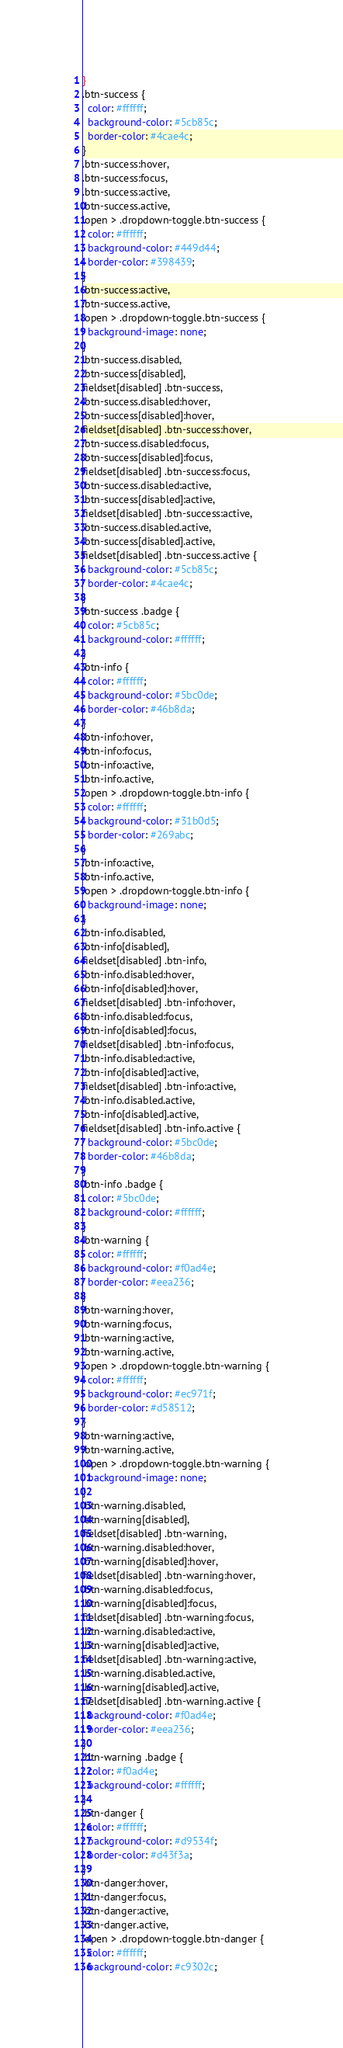<code> <loc_0><loc_0><loc_500><loc_500><_CSS_>}
.btn-success {
  color: #ffffff;
  background-color: #5cb85c;
  border-color: #4cae4c;
}
.btn-success:hover,
.btn-success:focus,
.btn-success:active,
.btn-success.active,
.open > .dropdown-toggle.btn-success {
  color: #ffffff;
  background-color: #449d44;
  border-color: #398439;
}
.btn-success:active,
.btn-success.active,
.open > .dropdown-toggle.btn-success {
  background-image: none;
}
.btn-success.disabled,
.btn-success[disabled],
fieldset[disabled] .btn-success,
.btn-success.disabled:hover,
.btn-success[disabled]:hover,
fieldset[disabled] .btn-success:hover,
.btn-success.disabled:focus,
.btn-success[disabled]:focus,
fieldset[disabled] .btn-success:focus,
.btn-success.disabled:active,
.btn-success[disabled]:active,
fieldset[disabled] .btn-success:active,
.btn-success.disabled.active,
.btn-success[disabled].active,
fieldset[disabled] .btn-success.active {
  background-color: #5cb85c;
  border-color: #4cae4c;
}
.btn-success .badge {
  color: #5cb85c;
  background-color: #ffffff;
}
.btn-info {
  color: #ffffff;
  background-color: #5bc0de;
  border-color: #46b8da;
}
.btn-info:hover,
.btn-info:focus,
.btn-info:active,
.btn-info.active,
.open > .dropdown-toggle.btn-info {
  color: #ffffff;
  background-color: #31b0d5;
  border-color: #269abc;
}
.btn-info:active,
.btn-info.active,
.open > .dropdown-toggle.btn-info {
  background-image: none;
}
.btn-info.disabled,
.btn-info[disabled],
fieldset[disabled] .btn-info,
.btn-info.disabled:hover,
.btn-info[disabled]:hover,
fieldset[disabled] .btn-info:hover,
.btn-info.disabled:focus,
.btn-info[disabled]:focus,
fieldset[disabled] .btn-info:focus,
.btn-info.disabled:active,
.btn-info[disabled]:active,
fieldset[disabled] .btn-info:active,
.btn-info.disabled.active,
.btn-info[disabled].active,
fieldset[disabled] .btn-info.active {
  background-color: #5bc0de;
  border-color: #46b8da;
}
.btn-info .badge {
  color: #5bc0de;
  background-color: #ffffff;
}
.btn-warning {
  color: #ffffff;
  background-color: #f0ad4e;
  border-color: #eea236;
}
.btn-warning:hover,
.btn-warning:focus,
.btn-warning:active,
.btn-warning.active,
.open > .dropdown-toggle.btn-warning {
  color: #ffffff;
  background-color: #ec971f;
  border-color: #d58512;
}
.btn-warning:active,
.btn-warning.active,
.open > .dropdown-toggle.btn-warning {
  background-image: none;
}
.btn-warning.disabled,
.btn-warning[disabled],
fieldset[disabled] .btn-warning,
.btn-warning.disabled:hover,
.btn-warning[disabled]:hover,
fieldset[disabled] .btn-warning:hover,
.btn-warning.disabled:focus,
.btn-warning[disabled]:focus,
fieldset[disabled] .btn-warning:focus,
.btn-warning.disabled:active,
.btn-warning[disabled]:active,
fieldset[disabled] .btn-warning:active,
.btn-warning.disabled.active,
.btn-warning[disabled].active,
fieldset[disabled] .btn-warning.active {
  background-color: #f0ad4e;
  border-color: #eea236;
}
.btn-warning .badge {
  color: #f0ad4e;
  background-color: #ffffff;
}
.btn-danger {
  color: #ffffff;
  background-color: #d9534f;
  border-color: #d43f3a;
}
.btn-danger:hover,
.btn-danger:focus,
.btn-danger:active,
.btn-danger.active,
.open > .dropdown-toggle.btn-danger {
  color: #ffffff;
  background-color: #c9302c;</code> 